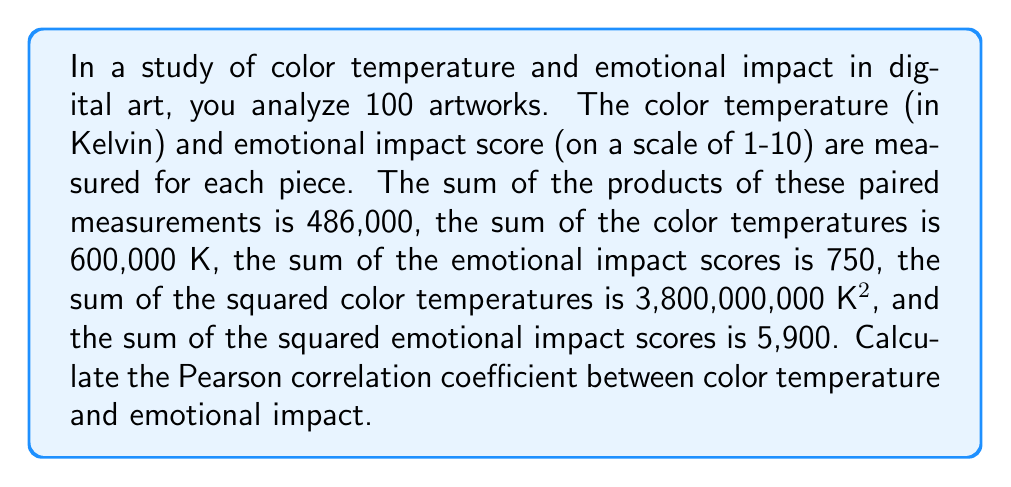Provide a solution to this math problem. To calculate the Pearson correlation coefficient, we'll use the formula:

$$r = \frac{n\sum xy - \sum x \sum y}{\sqrt{[n\sum x^2 - (\sum x)^2][n\sum y^2 - (\sum y)^2]}}$$

Where:
$n$ = number of pairs (artworks) = 100
$x$ = color temperature
$y$ = emotional impact score
$\sum xy$ = sum of the products = 486,000
$\sum x$ = sum of color temperatures = 600,000
$\sum y$ = sum of emotional impact scores = 750
$\sum x^2$ = sum of squared color temperatures = 3,800,000,000
$\sum y^2$ = sum of squared emotional impact scores = 5,900

Step 1: Calculate $n\sum xy$
$100 \times 486,000 = 48,600,000$

Step 2: Calculate $\sum x \sum y$
$600,000 \times 750 = 450,000,000$

Step 3: Calculate numerator
$48,600,000 - 450,000,000 = -401,400,000$

Step 4: Calculate $n\sum x^2$
$100 \times 3,800,000,000 = 380,000,000,000$

Step 5: Calculate $(\sum x)^2$
$600,000^2 = 360,000,000,000$

Step 6: Calculate $n\sum y^2$
$100 \times 5,900 = 590,000$

Step 7: Calculate $(\sum y)^2$
$750^2 = 562,500$

Step 8: Calculate denominator
$\sqrt{[380,000,000,000 - 360,000,000,000][590,000 - 562,500]}$
$= \sqrt{20,000,000,000 \times 27,500}$
$= \sqrt{550,000,000,000,000}$
$= 741,619,848.71$

Step 9: Calculate final correlation coefficient
$r = \frac{-401,400,000}{741,619,848.71} = -0.5412$
Answer: $-0.5412$ 